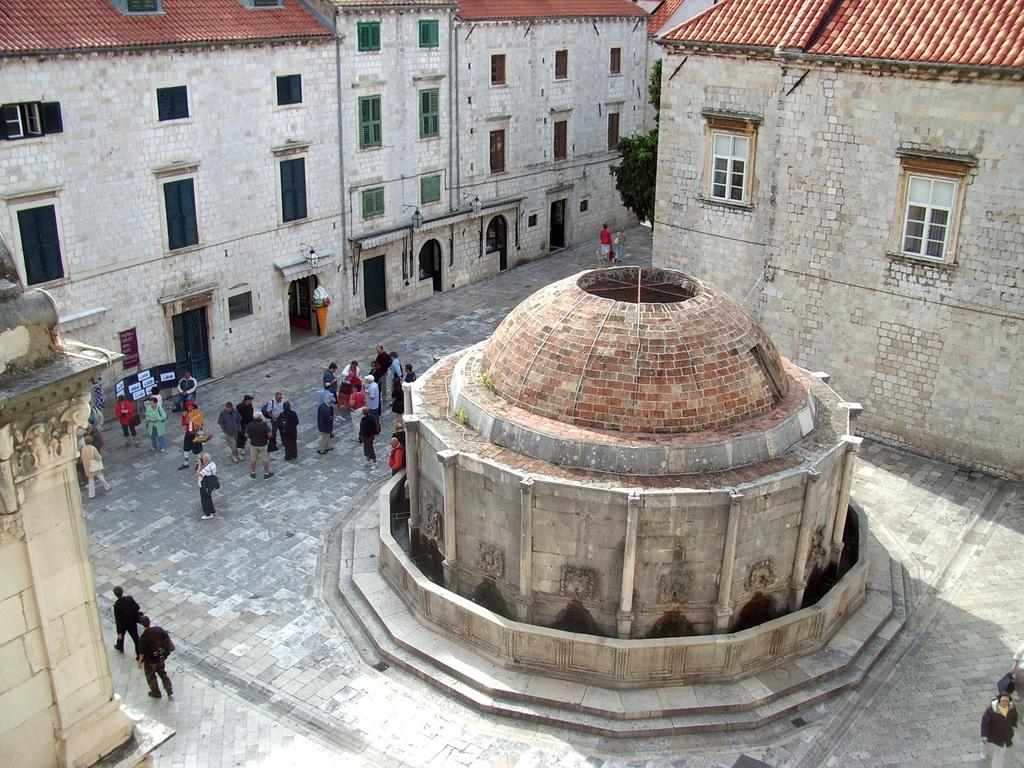What are the people in the image doing? The persons standing on the ground in the image are likely just standing or walking. What type of structures can be seen in the image? There are buildings in the image. Can you describe the wall in the image? There is a wall with a design in the image. What type of water feature is present in the image? There is a fountain in the image. What type of plant life is visible in the image? There is a tree in the image. What other objects can be seen in the image? There are additional objects present in the image, but their specific details are not mentioned in the provided facts. How many levels of jellyfish can be seen in the image? There are no jellyfish present in the image. What type of story is being told by the people standing in the image? The provided facts do not mention any story being told by the people in the image. 